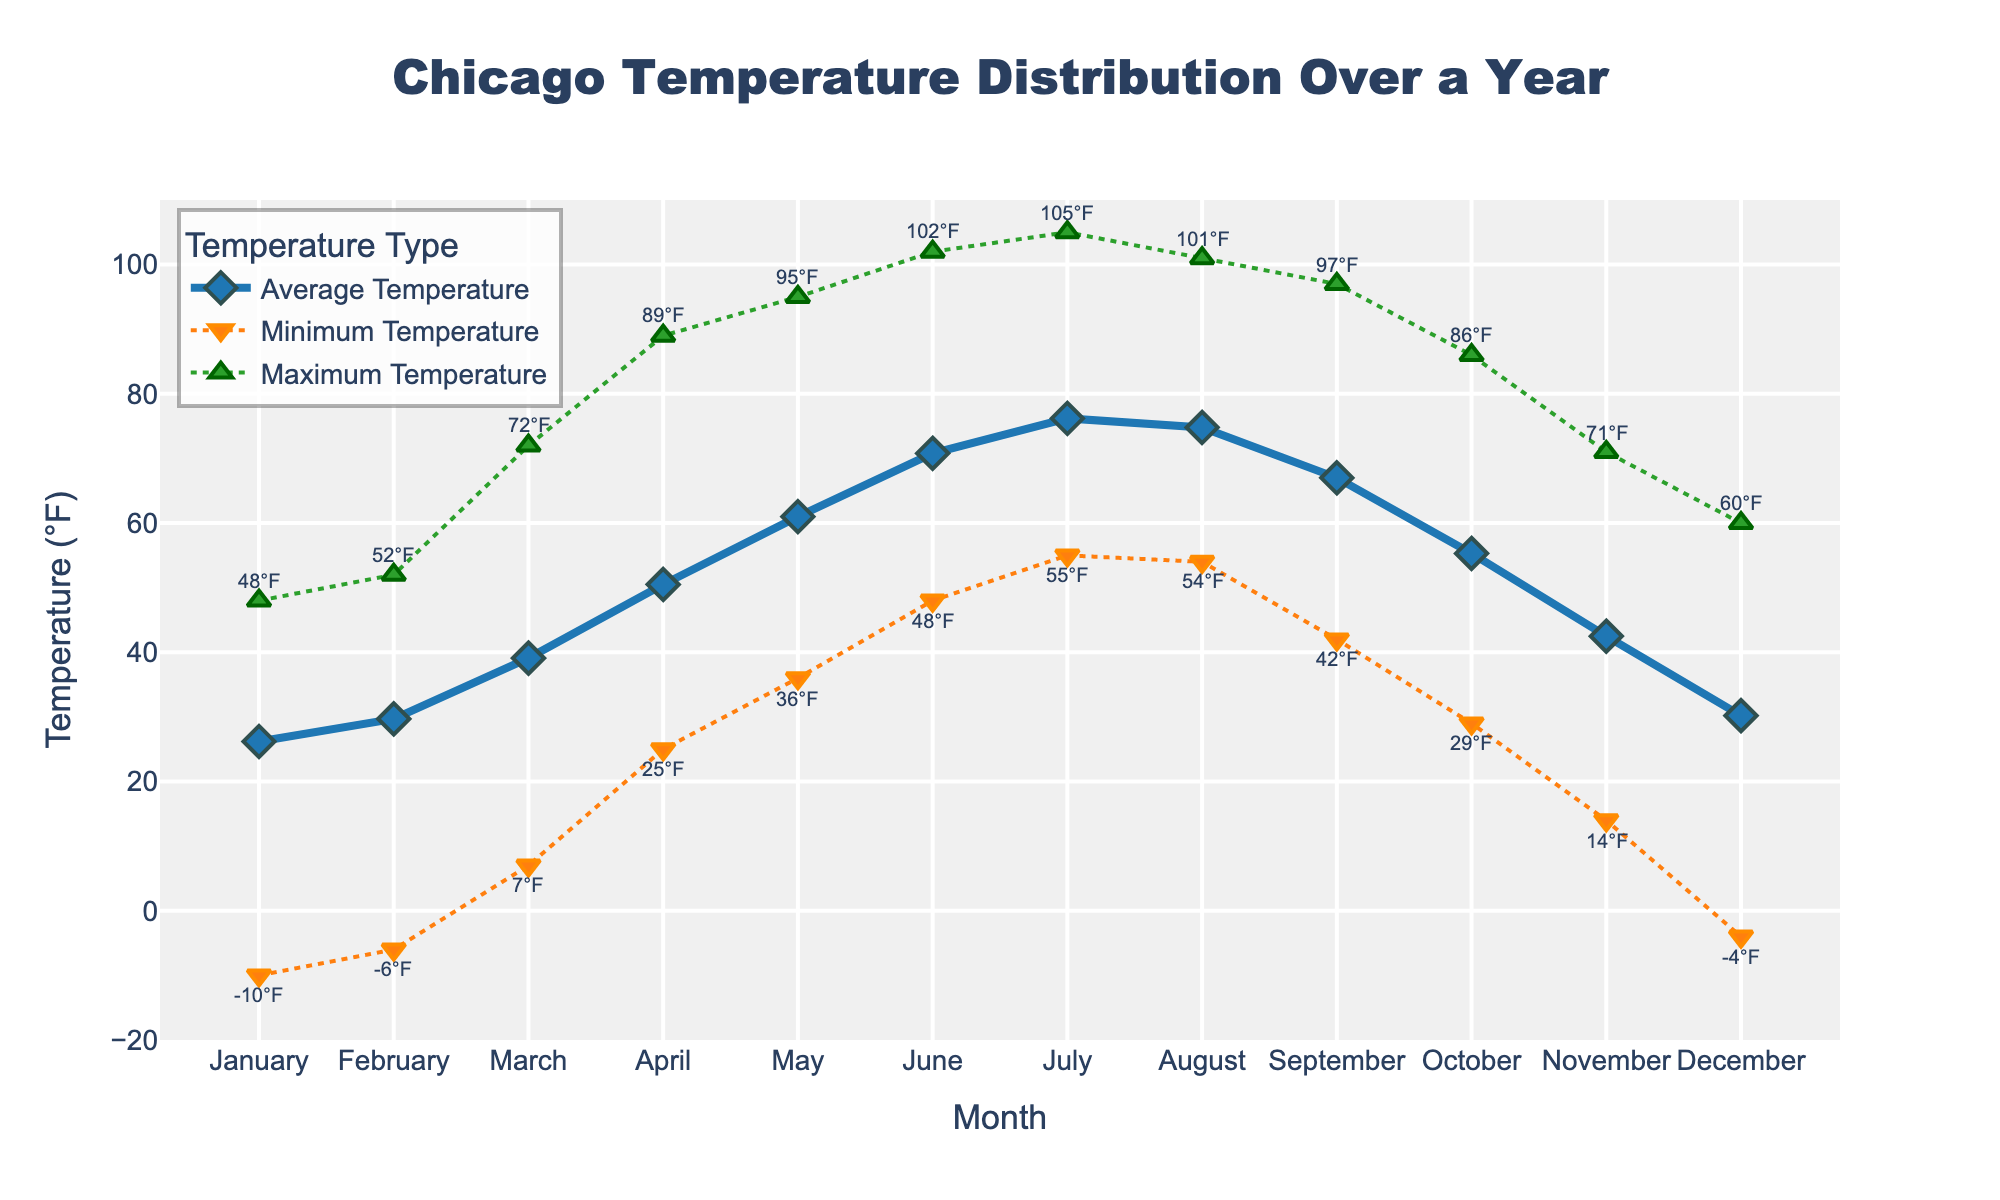What is the title of the figure? The title is usually placed at the top of the figure and it provides an overview of what the figure is about. In this case, it mentions a temperature distribution over a year in a specific location
Answer: Chicago Temperature Distribution Over a Year What does the x-axis represent? The x-axis represents the horizontal axis of the figure. Labels on it generally indicate categories or units of measurement, here it shows the months of the year
Answer: Month What is the highest average temperature month? For the highest average temperature, look at the "Average Temperature" line and identify the highest point along the y-axis, then find the corresponding month on the x-axis. The highest average temperature occurs in July
Answer: July Which month shows the lowest minimum temperature? To identify the lowest minimum temperature, examine the "Minimum Temperature" line and find the lowest point along the y-axis. The corresponding month on the x-axis will give the answer. January has the lowest minimum temperature at -10°F
Answer: January How does the average temperature trend change from January to December? Observe the "Average Temperature" line and note the general direction it takes from January to December. The trend shows a gradual increase in temperatures reaching a peak in July and then decreasing afterward
Answer: Increasing until July, then decreasing What is the difference between the maximum and minimum temperature in April? Find April on the x-axis and compare the corresponding values of "Maximum Temperature" and "Minimum Temperature." Subtract the minimum temperature from the maximum temperature to get the difference. In April, the max is 89°F and the min is 25°F, so the difference is 89 - 25
Answer: 64°F Which month has the most consistent temperature range (smallest difference between max and min temperature)? Calculate the temperature range for each month by subtracting the minimum temperature from the maximum temperature. Compare these ranges to find the smallest one. November has the smallest range (71 - 14 = 57°F)
Answer: November Compare the maximum temperatures of June and August. Which is higher? Look at the "Maximum Temperature" values for June and August. Compare their heights on the y-axis to determine which one is greater. June has a maximum of 102°F, and August has a maximum of 101°F
Answer: June During which month is the temperature most variable (greatest difference between max and min temperatures)? Calculate the temperature range for each month by subtracting the min temperature from the max temperature. The month with the highest range indicates the most variability. June has the largest range (102 - 48 = 54°F)
Answer: June What do the different line styles and markers represent in the chart? Identify the legends and match them with the different lines and markers in the figure. The lines and markers signify different temperature measures: solid line with diamonds for average temperature, dotted line with triangles down for minimum temperature, and dotted line with triangles up for maximum temperature
Answer: Different temperature measures (average, minimum, and maximum) 